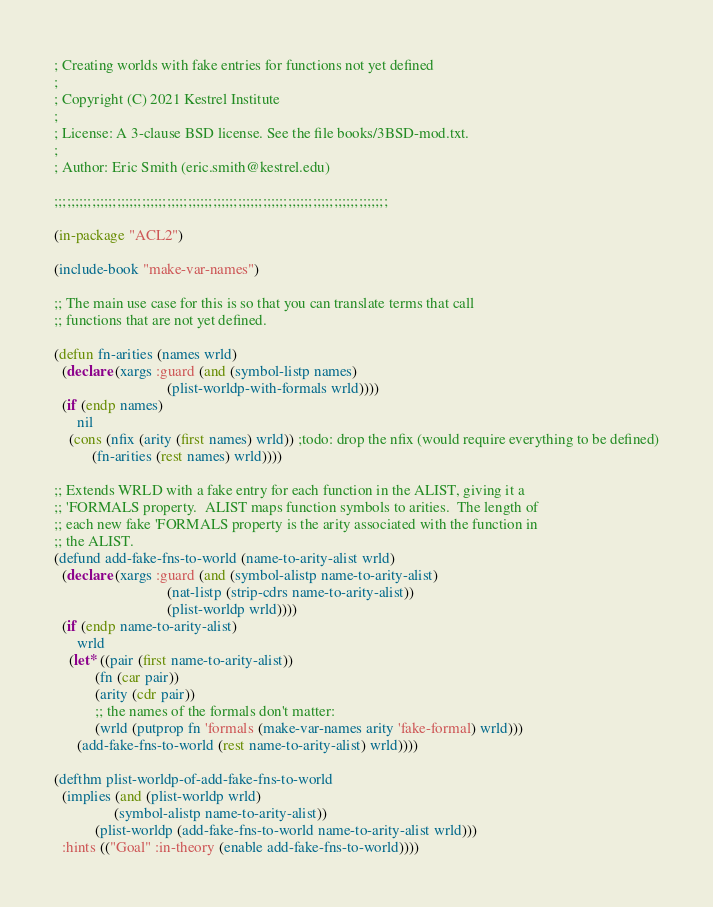Convert code to text. <code><loc_0><loc_0><loc_500><loc_500><_Lisp_>; Creating worlds with fake entries for functions not yet defined
;
; Copyright (C) 2021 Kestrel Institute
;
; License: A 3-clause BSD license. See the file books/3BSD-mod.txt.
;
; Author: Eric Smith (eric.smith@kestrel.edu)

;;;;;;;;;;;;;;;;;;;;;;;;;;;;;;;;;;;;;;;;;;;;;;;;;;;;;;;;;;;;;;;;;;;;;;;;;;;;;;;;

(in-package "ACL2")

(include-book "make-var-names")

;; The main use case for this is so that you can translate terms that call
;; functions that are not yet defined.

(defun fn-arities (names wrld)
  (declare (xargs :guard (and (symbol-listp names)
                              (plist-worldp-with-formals wrld))))
  (if (endp names)
      nil
    (cons (nfix (arity (first names) wrld)) ;todo: drop the nfix (would require everything to be defined)
          (fn-arities (rest names) wrld))))

;; Extends WRLD with a fake entry for each function in the ALIST, giving it a
;; 'FORMALS property.  ALIST maps function symbols to arities.  The length of
;; each new fake 'FORMALS property is the arity associated with the function in
;; the ALIST.
(defund add-fake-fns-to-world (name-to-arity-alist wrld)
  (declare (xargs :guard (and (symbol-alistp name-to-arity-alist)
                              (nat-listp (strip-cdrs name-to-arity-alist))
                              (plist-worldp wrld))))
  (if (endp name-to-arity-alist)
      wrld
    (let* ((pair (first name-to-arity-alist))
           (fn (car pair))
           (arity (cdr pair))
           ;; the names of the formals don't matter:
           (wrld (putprop fn 'formals (make-var-names arity 'fake-formal) wrld)))
      (add-fake-fns-to-world (rest name-to-arity-alist) wrld))))

(defthm plist-worldp-of-add-fake-fns-to-world
  (implies (and (plist-worldp wrld)
                (symbol-alistp name-to-arity-alist))
           (plist-worldp (add-fake-fns-to-world name-to-arity-alist wrld)))
  :hints (("Goal" :in-theory (enable add-fake-fns-to-world))))
</code> 